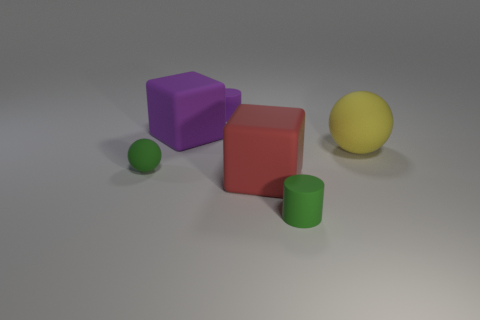Is the number of large rubber blocks in front of the green rubber cylinder the same as the number of red things?
Your answer should be compact. No. Is the big object that is behind the big yellow ball made of the same material as the tiny green thing that is to the left of the purple cube?
Your answer should be compact. Yes. Is there any other thing that has the same material as the big ball?
Make the answer very short. Yes. There is a tiny green thing to the right of the red object; does it have the same shape as the purple thing that is in front of the tiny purple matte cylinder?
Keep it short and to the point. No. Are there fewer big yellow rubber spheres behind the big yellow ball than small red blocks?
Make the answer very short. No. What number of cylinders are the same color as the big sphere?
Provide a succinct answer. 0. What is the size of the sphere right of the red cube?
Provide a short and direct response. Large. What is the shape of the tiny matte thing that is right of the small rubber cylinder behind the matte sphere to the left of the green rubber cylinder?
Make the answer very short. Cylinder. There is a large object that is behind the red matte cube and in front of the large purple matte cube; what shape is it?
Your response must be concise. Sphere. Is there a gray ball of the same size as the purple block?
Offer a very short reply. No. 